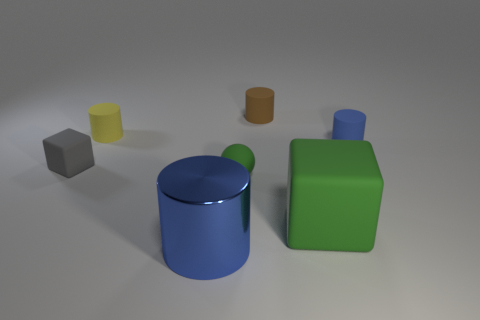Subtract all matte cylinders. How many cylinders are left? 1 Subtract all brown cylinders. How many cylinders are left? 3 Add 1 big green matte cylinders. How many objects exist? 8 Subtract all cubes. How many objects are left? 5 Subtract 1 spheres. How many spheres are left? 0 Subtract all blue matte objects. Subtract all yellow rubber cylinders. How many objects are left? 5 Add 3 blue metallic things. How many blue metallic things are left? 4 Add 1 brown objects. How many brown objects exist? 2 Subtract 0 green cylinders. How many objects are left? 7 Subtract all blue blocks. Subtract all yellow cylinders. How many blocks are left? 2 